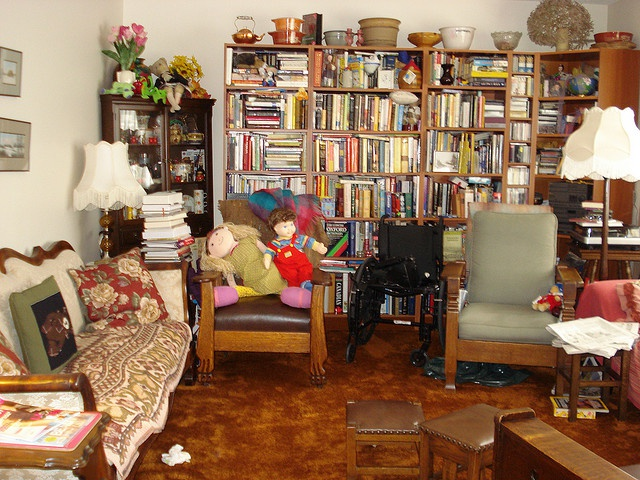Describe the objects in this image and their specific colors. I can see couch in lightgray, tan, gray, and maroon tones, chair in lightgray, gray, brown, and maroon tones, book in lightgray, beige, tan, and gray tones, chair in lightgray, brown, maroon, and black tones, and couch in lightgray, brown, and maroon tones in this image. 